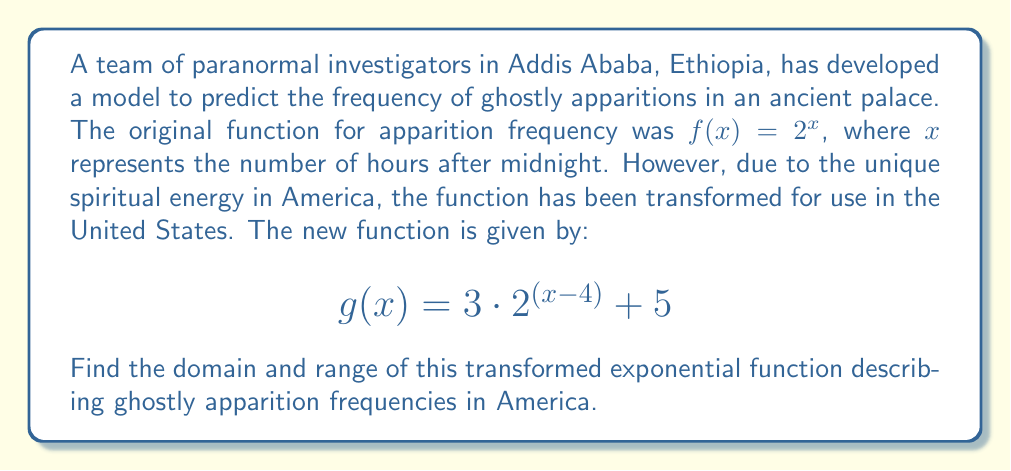Can you solve this math problem? To find the domain and range of the transformed exponential function, let's analyze it step by step:

1. Original function: $f(x) = 2^x$
   Transformed function: $g(x) = 3 \cdot 2^{(x-4)} + 5$

2. Domain:
   The domain of an exponential function is typically all real numbers. The transformations applied to the original function (horizontal shift, vertical stretch, and vertical shift) do not affect the domain. Therefore, the domain of $g(x)$ is all real numbers.

3. Range:
   To find the range, let's analyze the transformations:
   a) Inside the parentheses: $(x-4)$ represents a horizontal shift 4 units to the right
   b) Outside the parentheses: $3 \cdot (\ldots)$ represents a vertical stretch by a factor of 3
   c) $+5$ at the end represents a vertical shift 5 units up

   Let's consider the range step by step:
   - The range of $2^x$ is $(0, \infty)$
   - The range of $2^{(x-4)}$ is still $(0, \infty)$
   - The range of $3 \cdot 2^{(x-4)}$ is $(0, \infty)$
   - Finally, the range of $3 \cdot 2^{(x-4)} + 5$ is $(5, \infty)$

   This means the lowest possible value for $g(x)$ is 5, which occurs as $x$ approaches negative infinity, and there is no upper bound.
Answer: Domain: $(-\infty, \infty)$
Range: $(5, \infty)$ 